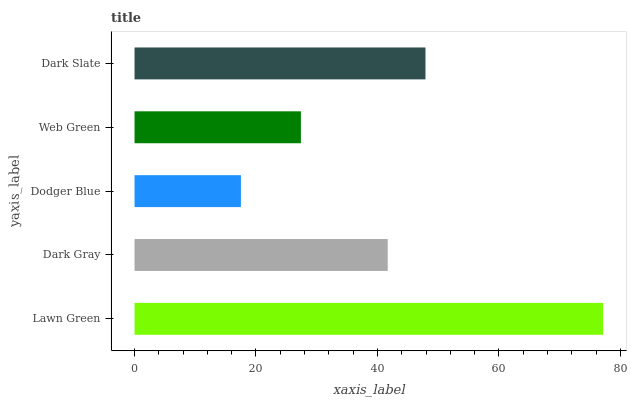Is Dodger Blue the minimum?
Answer yes or no. Yes. Is Lawn Green the maximum?
Answer yes or no. Yes. Is Dark Gray the minimum?
Answer yes or no. No. Is Dark Gray the maximum?
Answer yes or no. No. Is Lawn Green greater than Dark Gray?
Answer yes or no. Yes. Is Dark Gray less than Lawn Green?
Answer yes or no. Yes. Is Dark Gray greater than Lawn Green?
Answer yes or no. No. Is Lawn Green less than Dark Gray?
Answer yes or no. No. Is Dark Gray the high median?
Answer yes or no. Yes. Is Dark Gray the low median?
Answer yes or no. Yes. Is Dark Slate the high median?
Answer yes or no. No. Is Dodger Blue the low median?
Answer yes or no. No. 